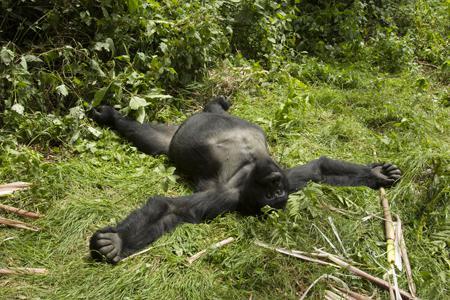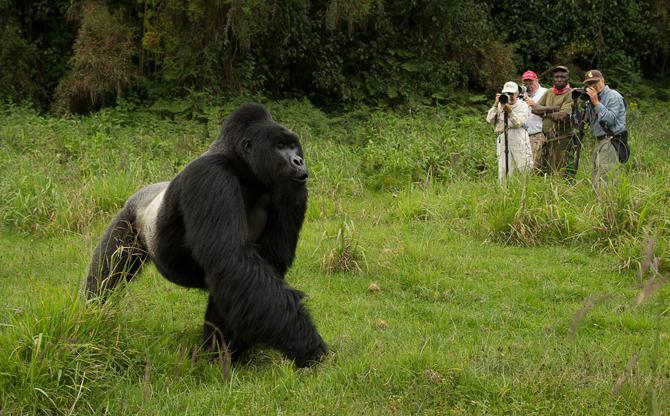The first image is the image on the left, the second image is the image on the right. For the images displayed, is the sentence "There are two gorillas in one picture and one in the other." factually correct? Answer yes or no. No. The first image is the image on the left, the second image is the image on the right. Given the left and right images, does the statement "The left image shows one adult gorilla on all fours, and the right image shows one adult gorilla with a frowning face looking directly at the camera." hold true? Answer yes or no. No. 